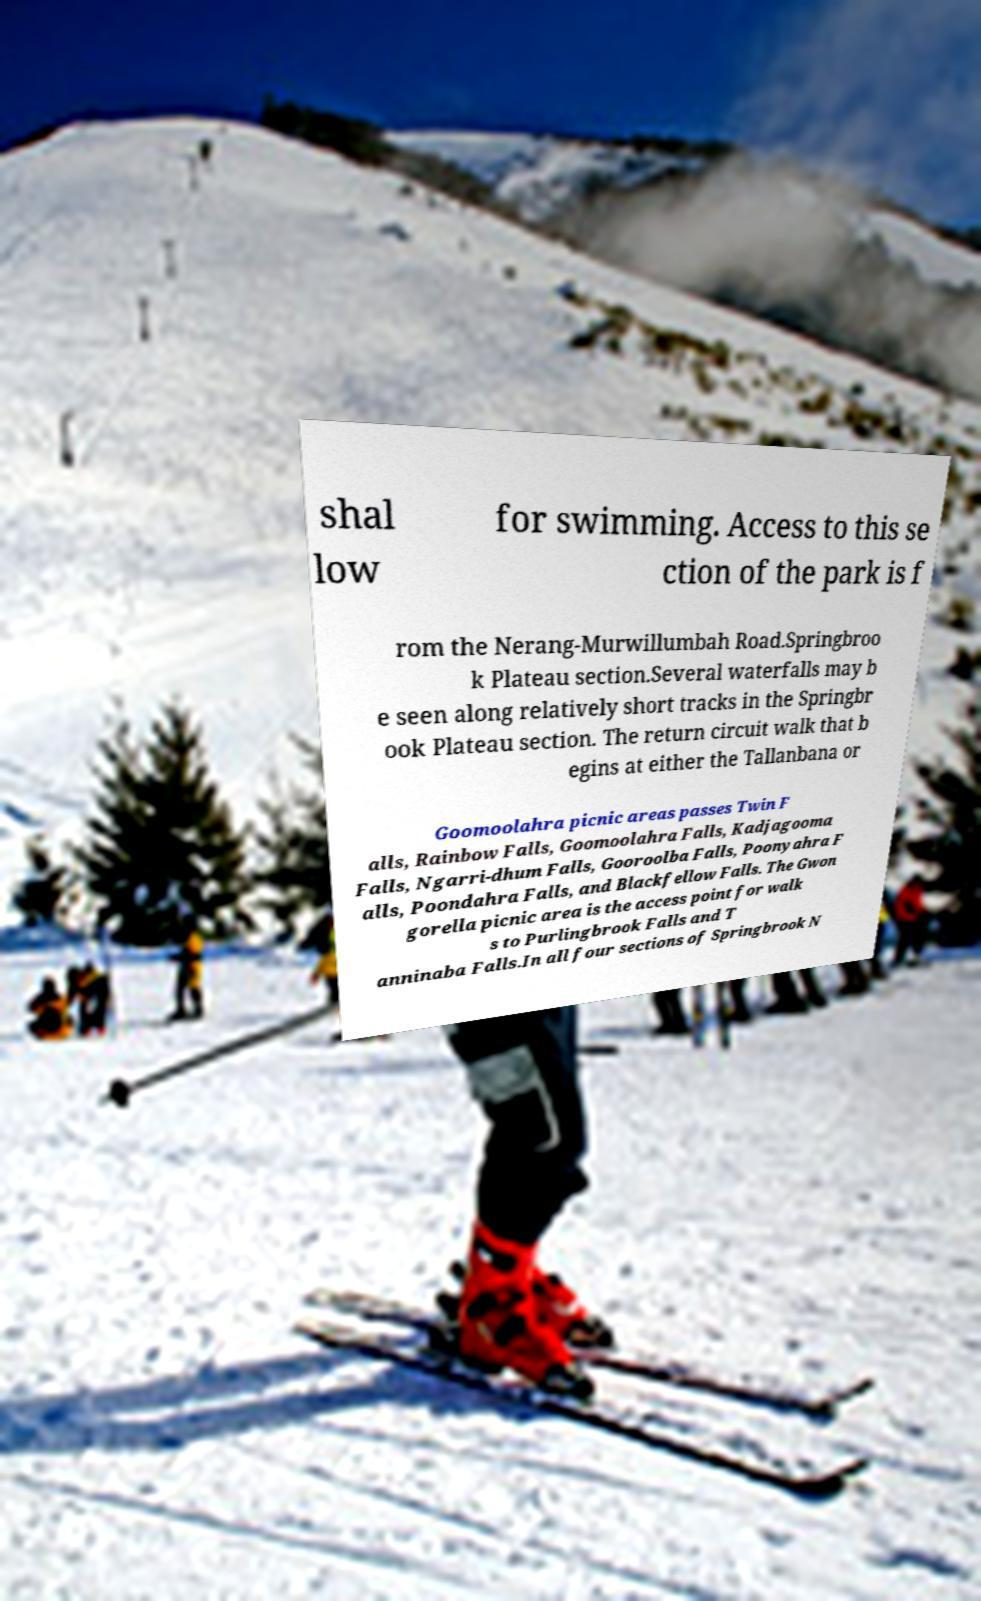Please identify and transcribe the text found in this image. shal low for swimming. Access to this se ction of the park is f rom the Nerang-Murwillumbah Road.Springbroo k Plateau section.Several waterfalls may b e seen along relatively short tracks in the Springbr ook Plateau section. The return circuit walk that b egins at either the Tallanbana or Goomoolahra picnic areas passes Twin F alls, Rainbow Falls, Goomoolahra Falls, Kadjagooma Falls, Ngarri-dhum Falls, Gooroolba Falls, Poonyahra F alls, Poondahra Falls, and Blackfellow Falls. The Gwon gorella picnic area is the access point for walk s to Purlingbrook Falls and T anninaba Falls.In all four sections of Springbrook N 